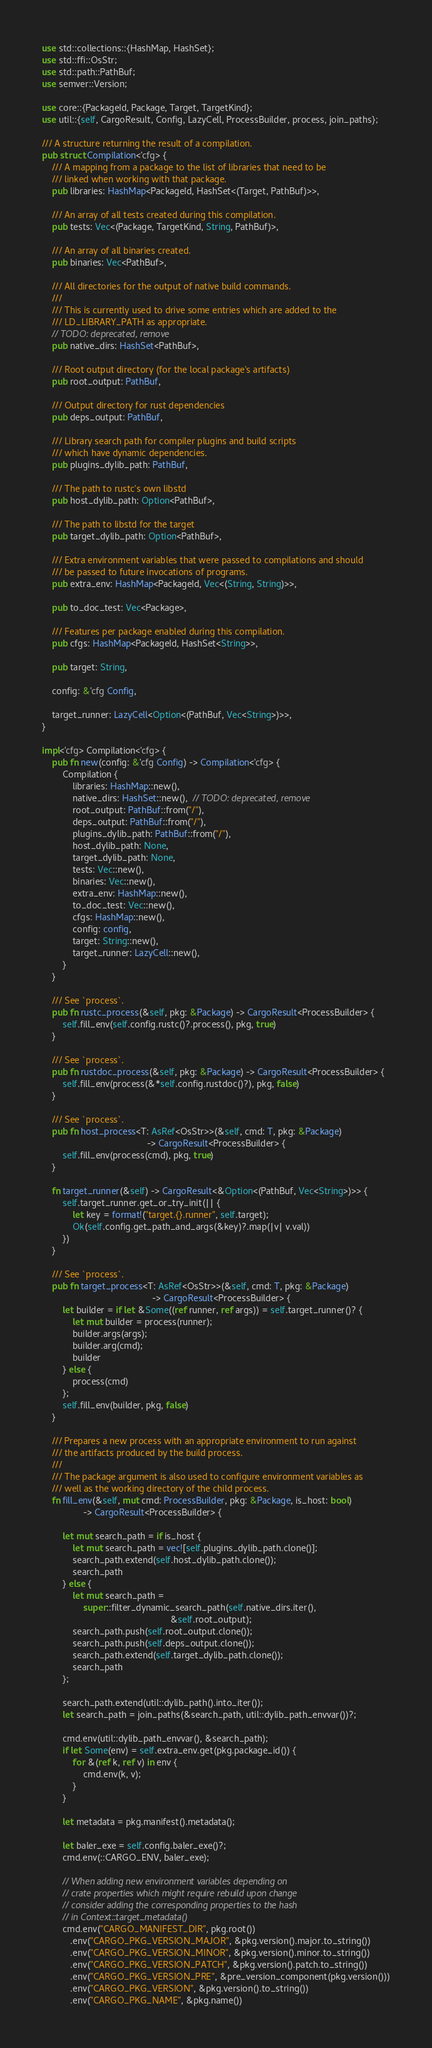Convert code to text. <code><loc_0><loc_0><loc_500><loc_500><_Rust_>use std::collections::{HashMap, HashSet};
use std::ffi::OsStr;
use std::path::PathBuf;
use semver::Version;

use core::{PackageId, Package, Target, TargetKind};
use util::{self, CargoResult, Config, LazyCell, ProcessBuilder, process, join_paths};

/// A structure returning the result of a compilation.
pub struct Compilation<'cfg> {
    /// A mapping from a package to the list of libraries that need to be
    /// linked when working with that package.
    pub libraries: HashMap<PackageId, HashSet<(Target, PathBuf)>>,

    /// An array of all tests created during this compilation.
    pub tests: Vec<(Package, TargetKind, String, PathBuf)>,

    /// An array of all binaries created.
    pub binaries: Vec<PathBuf>,

    /// All directories for the output of native build commands.
    ///
    /// This is currently used to drive some entries which are added to the
    /// LD_LIBRARY_PATH as appropriate.
    // TODO: deprecated, remove
    pub native_dirs: HashSet<PathBuf>,

    /// Root output directory (for the local package's artifacts)
    pub root_output: PathBuf,

    /// Output directory for rust dependencies
    pub deps_output: PathBuf,

    /// Library search path for compiler plugins and build scripts
    /// which have dynamic dependencies.
    pub plugins_dylib_path: PathBuf,

    /// The path to rustc's own libstd
    pub host_dylib_path: Option<PathBuf>,

    /// The path to libstd for the target
    pub target_dylib_path: Option<PathBuf>,

    /// Extra environment variables that were passed to compilations and should
    /// be passed to future invocations of programs.
    pub extra_env: HashMap<PackageId, Vec<(String, String)>>,

    pub to_doc_test: Vec<Package>,

    /// Features per package enabled during this compilation.
    pub cfgs: HashMap<PackageId, HashSet<String>>,

    pub target: String,

    config: &'cfg Config,

    target_runner: LazyCell<Option<(PathBuf, Vec<String>)>>,
}

impl<'cfg> Compilation<'cfg> {
    pub fn new(config: &'cfg Config) -> Compilation<'cfg> {
        Compilation {
            libraries: HashMap::new(),
            native_dirs: HashSet::new(),  // TODO: deprecated, remove
            root_output: PathBuf::from("/"),
            deps_output: PathBuf::from("/"),
            plugins_dylib_path: PathBuf::from("/"),
            host_dylib_path: None,
            target_dylib_path: None,
            tests: Vec::new(),
            binaries: Vec::new(),
            extra_env: HashMap::new(),
            to_doc_test: Vec::new(),
            cfgs: HashMap::new(),
            config: config,
            target: String::new(),
            target_runner: LazyCell::new(),
        }
    }

    /// See `process`.
    pub fn rustc_process(&self, pkg: &Package) -> CargoResult<ProcessBuilder> {
        self.fill_env(self.config.rustc()?.process(), pkg, true)
    }

    /// See `process`.
    pub fn rustdoc_process(&self, pkg: &Package) -> CargoResult<ProcessBuilder> {
        self.fill_env(process(&*self.config.rustdoc()?), pkg, false)
    }

    /// See `process`.
    pub fn host_process<T: AsRef<OsStr>>(&self, cmd: T, pkg: &Package)
                                         -> CargoResult<ProcessBuilder> {
        self.fill_env(process(cmd), pkg, true)
    }

    fn target_runner(&self) -> CargoResult<&Option<(PathBuf, Vec<String>)>> {
        self.target_runner.get_or_try_init(|| {
            let key = format!("target.{}.runner", self.target);
            Ok(self.config.get_path_and_args(&key)?.map(|v| v.val))
        })
    }

    /// See `process`.
    pub fn target_process<T: AsRef<OsStr>>(&self, cmd: T, pkg: &Package)
                                           -> CargoResult<ProcessBuilder> {
        let builder = if let &Some((ref runner, ref args)) = self.target_runner()? {
            let mut builder = process(runner);
            builder.args(args);
            builder.arg(cmd);
            builder
        } else {
            process(cmd)
        };
        self.fill_env(builder, pkg, false)
    }

    /// Prepares a new process with an appropriate environment to run against
    /// the artifacts produced by the build process.
    ///
    /// The package argument is also used to configure environment variables as
    /// well as the working directory of the child process.
    fn fill_env(&self, mut cmd: ProcessBuilder, pkg: &Package, is_host: bool)
                -> CargoResult<ProcessBuilder> {

        let mut search_path = if is_host {
            let mut search_path = vec![self.plugins_dylib_path.clone()];
            search_path.extend(self.host_dylib_path.clone());
            search_path
        } else {
            let mut search_path =
                super::filter_dynamic_search_path(self.native_dirs.iter(),
                                                  &self.root_output);
            search_path.push(self.root_output.clone());
            search_path.push(self.deps_output.clone());
            search_path.extend(self.target_dylib_path.clone());
            search_path
        };

        search_path.extend(util::dylib_path().into_iter());
        let search_path = join_paths(&search_path, util::dylib_path_envvar())?;

        cmd.env(util::dylib_path_envvar(), &search_path);
        if let Some(env) = self.extra_env.get(pkg.package_id()) {
            for &(ref k, ref v) in env {
                cmd.env(k, v);
            }
        }

        let metadata = pkg.manifest().metadata();

        let baler_exe = self.config.baler_exe()?;
        cmd.env(::CARGO_ENV, baler_exe);

        // When adding new environment variables depending on
        // crate properties which might require rebuild upon change
        // consider adding the corresponding properties to the hash
        // in Context::target_metadata()
        cmd.env("CARGO_MANIFEST_DIR", pkg.root())
           .env("CARGO_PKG_VERSION_MAJOR", &pkg.version().major.to_string())
           .env("CARGO_PKG_VERSION_MINOR", &pkg.version().minor.to_string())
           .env("CARGO_PKG_VERSION_PATCH", &pkg.version().patch.to_string())
           .env("CARGO_PKG_VERSION_PRE", &pre_version_component(pkg.version()))
           .env("CARGO_PKG_VERSION", &pkg.version().to_string())
           .env("CARGO_PKG_NAME", &pkg.name())</code> 